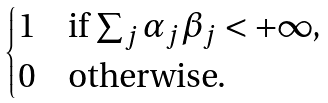<formula> <loc_0><loc_0><loc_500><loc_500>\begin{cases} 1 & \text {if $\sum_{j} \alpha_{j}\beta_{j} < +\infty$,} \\ 0 & \text {otherwise.} \end{cases}</formula> 